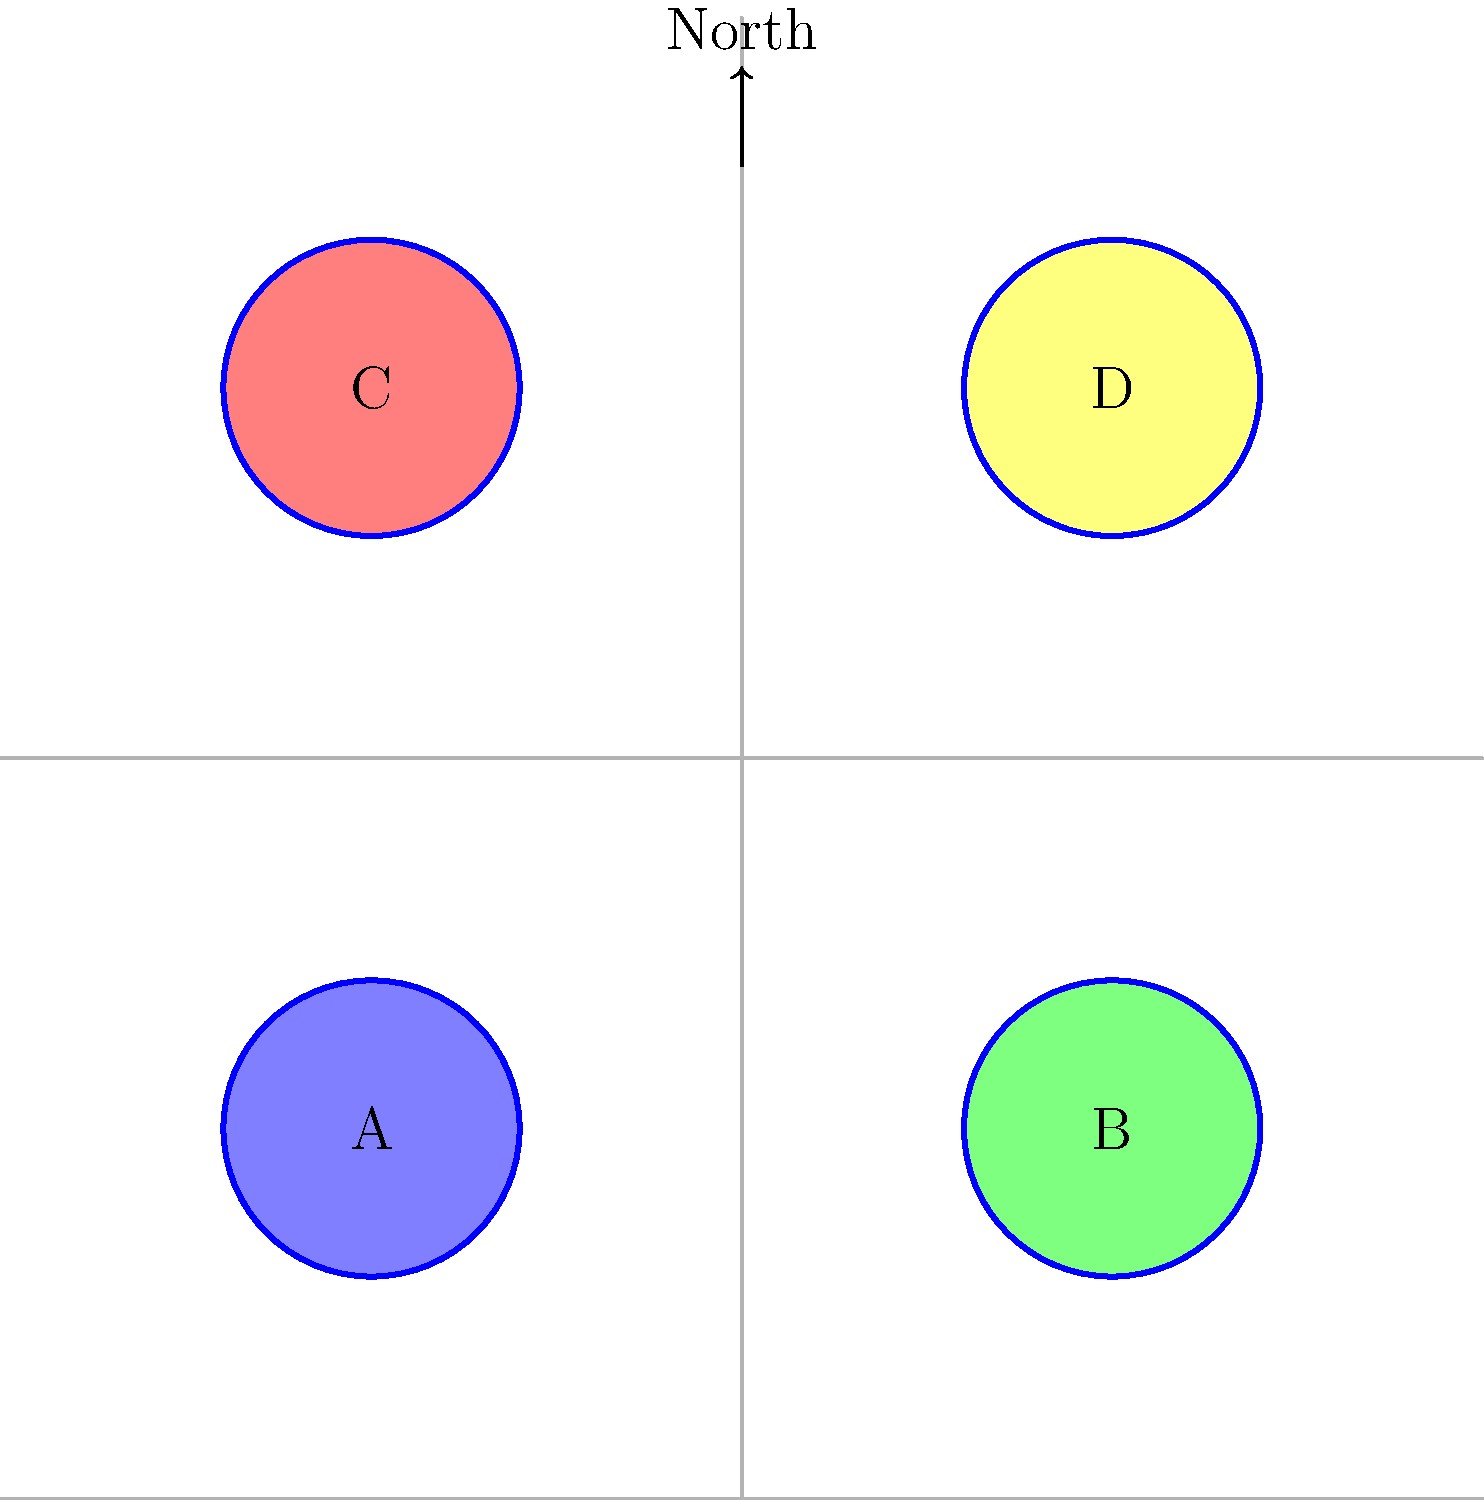In this aerial view of Timaru's historical landmarks, which letter corresponds to the location of the Caroline Bay Soundshell, a prominent structure built in 1938 for outdoor performances? To answer this question, we need to analyze the aerial view and consider the historical context of Timaru's landmarks:

1. The image shows four landmarks labeled A, B, C, and D, with roads dividing the area into quadrants.

2. The Caroline Bay Soundshell is a significant historical structure in Timaru, built in 1938 for outdoor performances.

3. Caroline Bay is located on the northern coast of Timaru, which would be towards the top of the image.

4. The Soundshell would likely be situated near the beach, as it was designed for outdoor performances.

5. Given this information, we can deduce that the landmark closest to the northern edge of the image and potentially near the coastline would be the most likely location for the Caroline Bay Soundshell.

6. Looking at the image, the landmark labeled C is positioned in the upper-left quadrant, making it the northernmost point among the four landmarks.

7. This position aligns with the expected location of the Caroline Bay Soundshell, being close to the northern coast of Timaru.

Therefore, the letter C most likely corresponds to the location of the Caroline Bay Soundshell.
Answer: C 